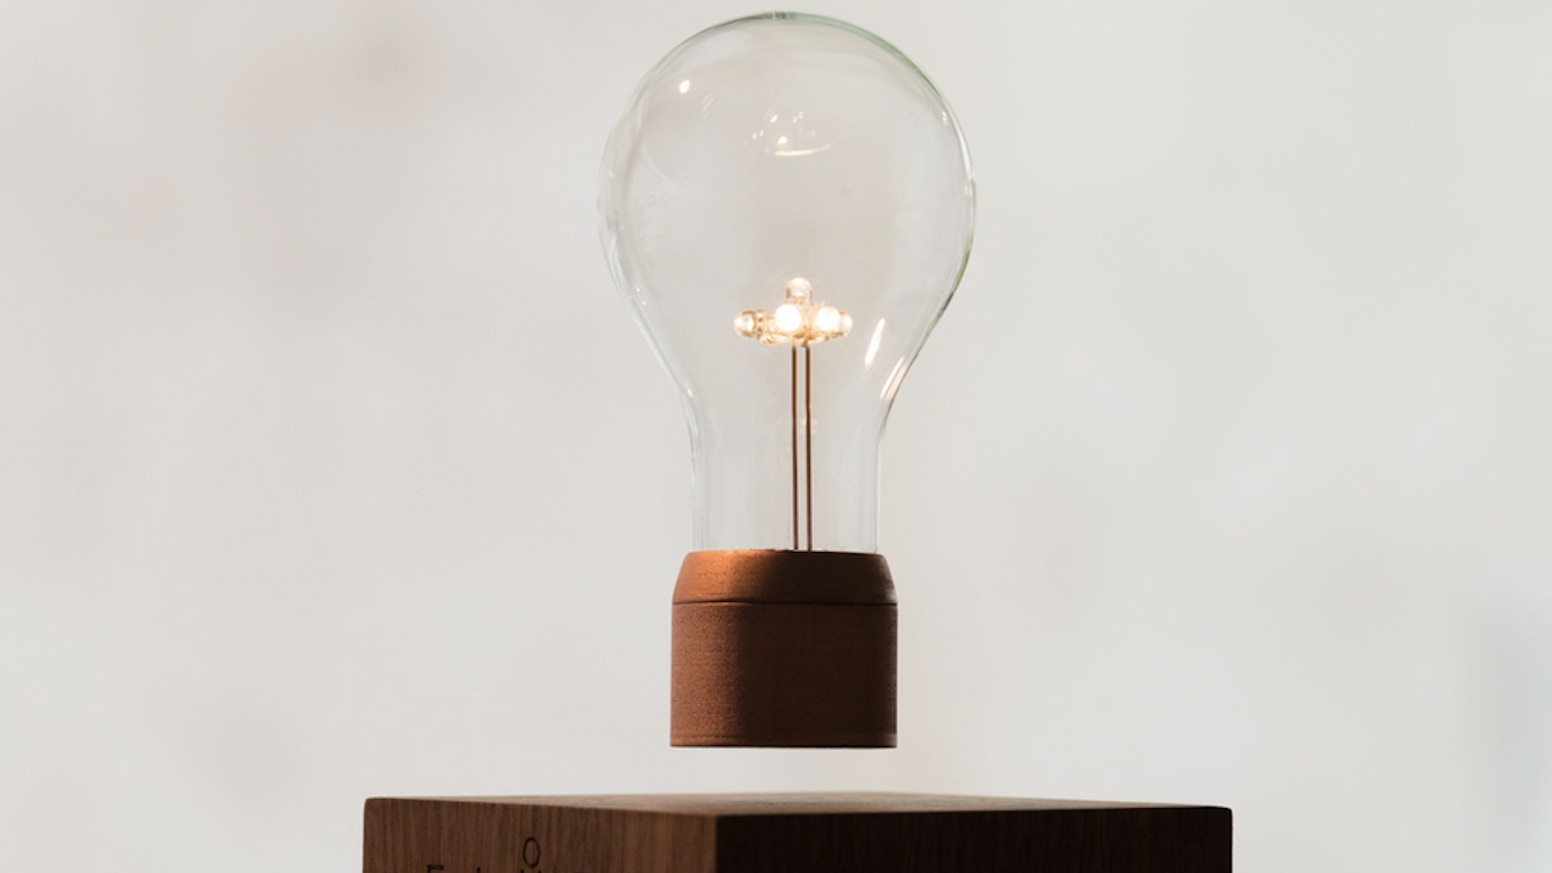What kind of filament design is used within the light bulb, and what does it suggest about the type of light it emits? The light bulb features a spiral filament composed of multiple small arms that extend from a central point. This design is often seen in decorative bulbs that aim to combine classic aesthetics with modern technology. The spiral design allows for an even distribution of light, reminiscent of vintage Edison bulbs, suggesting a warm, ambient glow. Such a setup is generally used in settings where mood lighting is preferred, often employing incandescent or carbon filament technology rather than LED, to enhance the bulb's vintage appeal. 